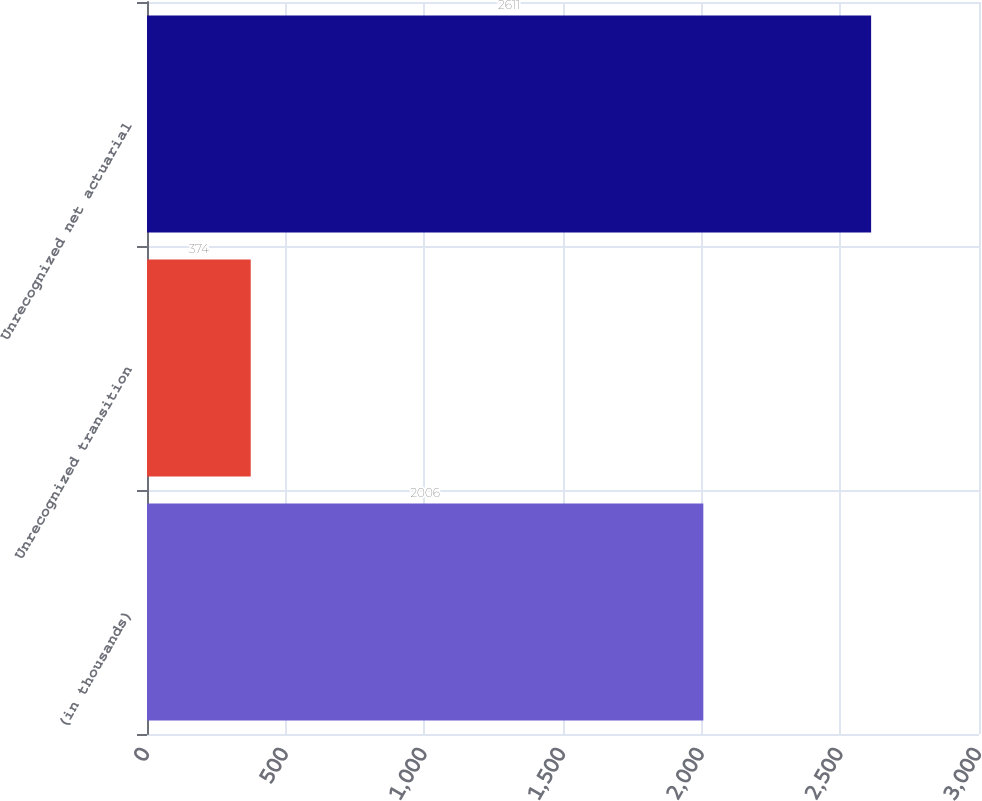Convert chart. <chart><loc_0><loc_0><loc_500><loc_500><bar_chart><fcel>(in thousands)<fcel>Unrecognized transition<fcel>Unrecognized net actuarial<nl><fcel>2006<fcel>374<fcel>2611<nl></chart> 